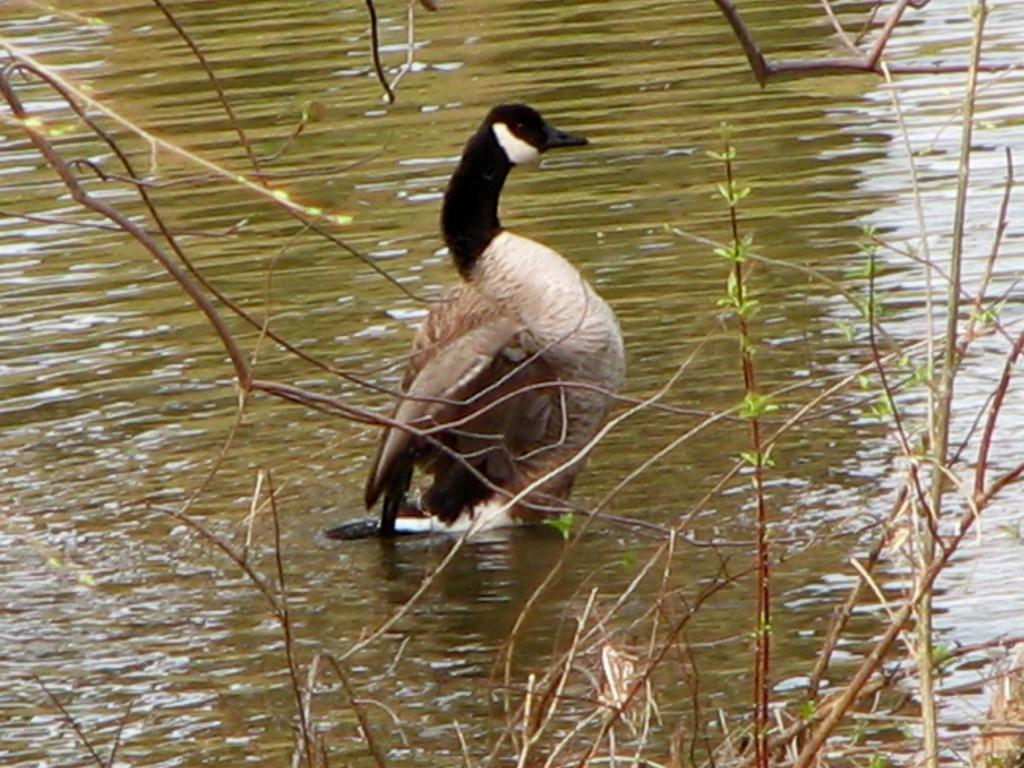What animal is on the surface of the water in the image? There is a duck on the surface of the water in the image. What else can be seen in the image besides the duck? There are plants visible in the image. What type of vacation is the woman enjoying in the image? There is no woman or vacation present in the image; it features a duck on the water and plants. 